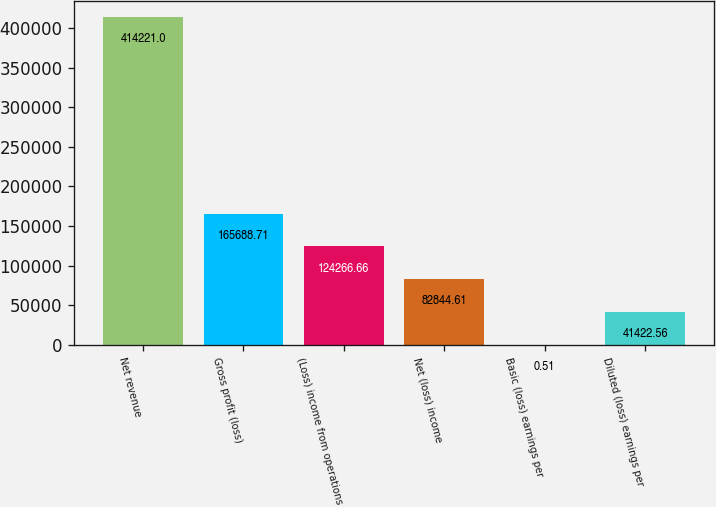<chart> <loc_0><loc_0><loc_500><loc_500><bar_chart><fcel>Net revenue<fcel>Gross profit (loss)<fcel>(Loss) income from operations<fcel>Net (loss) income<fcel>Basic (loss) earnings per<fcel>Diluted (loss) earnings per<nl><fcel>414221<fcel>165689<fcel>124267<fcel>82844.6<fcel>0.51<fcel>41422.6<nl></chart> 